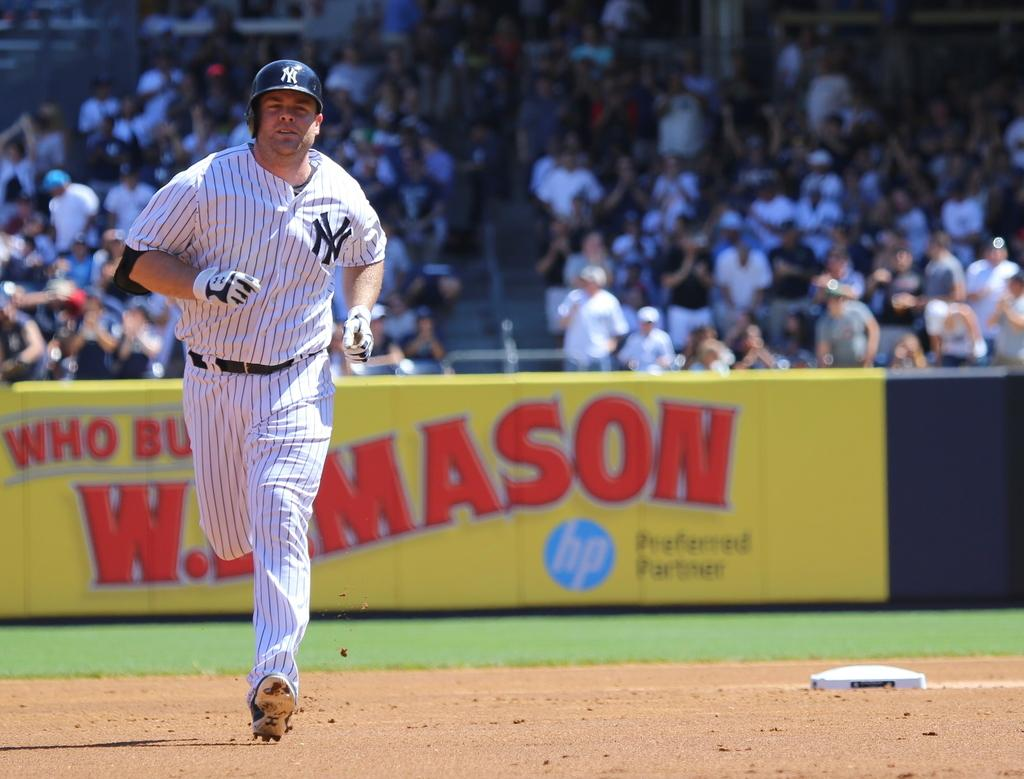<image>
Offer a succinct explanation of the picture presented. A new york yankees playing running the bases during a baseball game. 